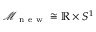Convert formula to latex. <formula><loc_0><loc_0><loc_500><loc_500>\mathcal { M } _ { n e w } \cong \mathbb { R } \times S ^ { 1 }</formula> 